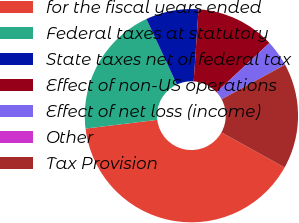<chart> <loc_0><loc_0><loc_500><loc_500><pie_chart><fcel>for the fiscal years ended<fcel>Federal taxes at statutory<fcel>State taxes net of federal tax<fcel>Effect of non-US operations<fcel>Effect of net loss (income)<fcel>Other<fcel>Tax Provision<nl><fcel>40.0%<fcel>20.0%<fcel>8.0%<fcel>12.0%<fcel>4.0%<fcel>0.0%<fcel>16.0%<nl></chart> 